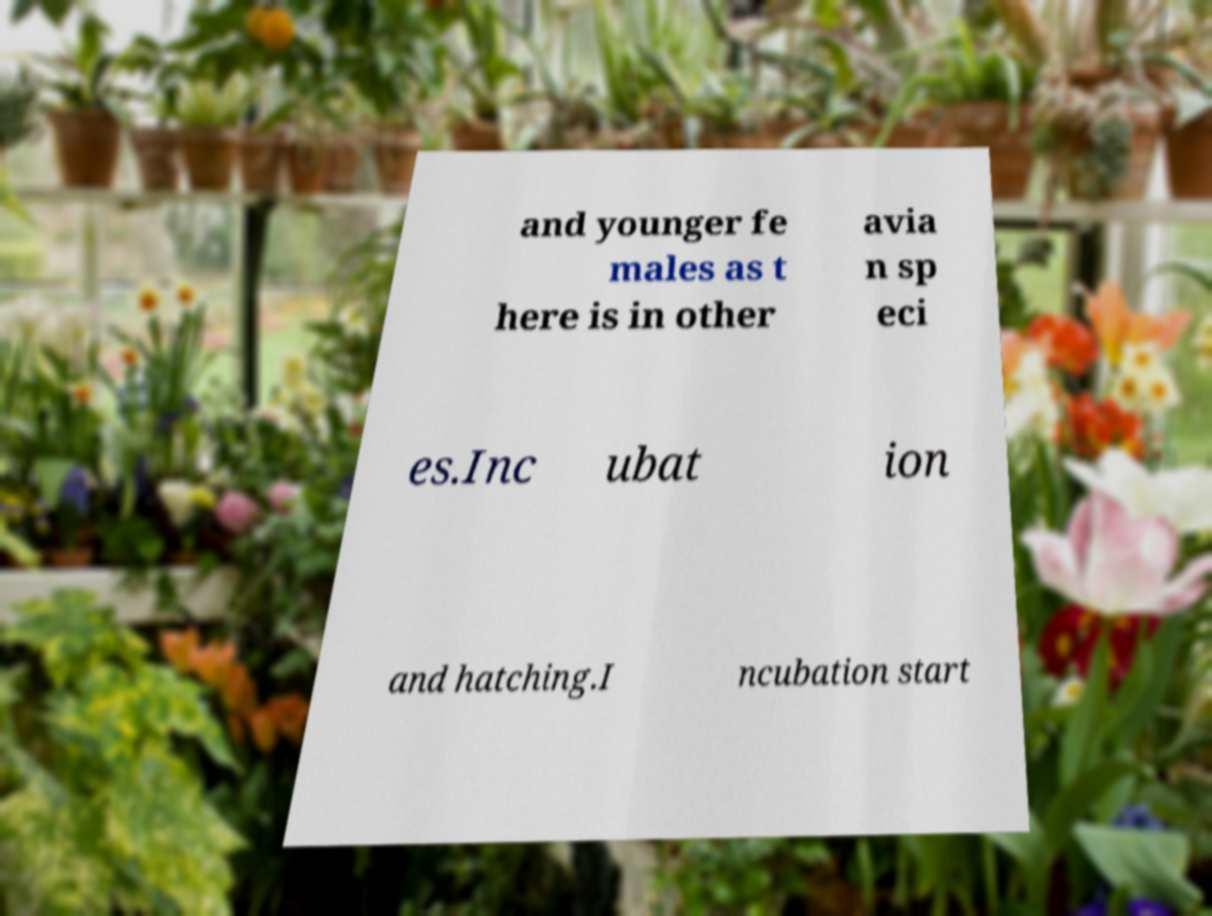I need the written content from this picture converted into text. Can you do that? and younger fe males as t here is in other avia n sp eci es.Inc ubat ion and hatching.I ncubation start 